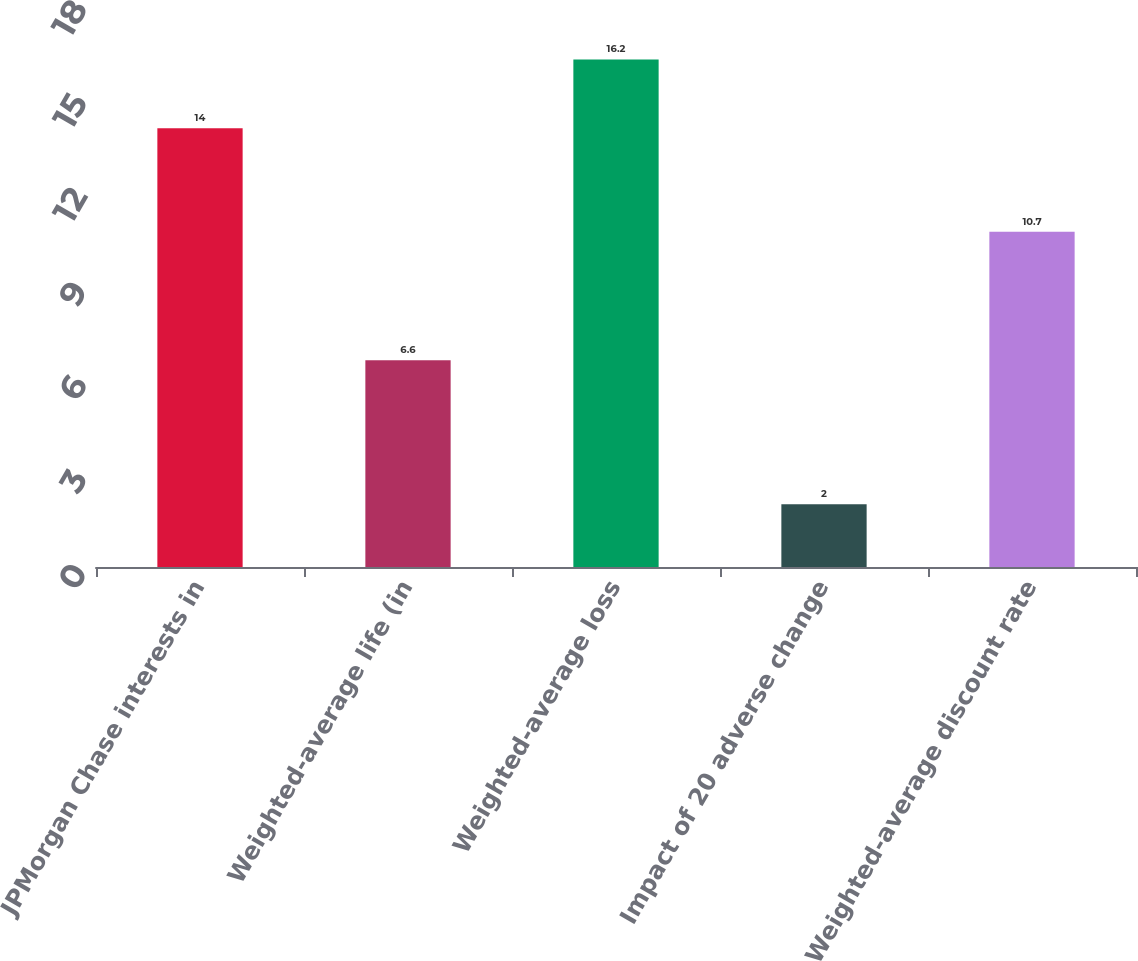Convert chart to OTSL. <chart><loc_0><loc_0><loc_500><loc_500><bar_chart><fcel>JPMorgan Chase interests in<fcel>Weighted-average life (in<fcel>Weighted-average loss<fcel>Impact of 20 adverse change<fcel>Weighted-average discount rate<nl><fcel>14<fcel>6.6<fcel>16.2<fcel>2<fcel>10.7<nl></chart> 